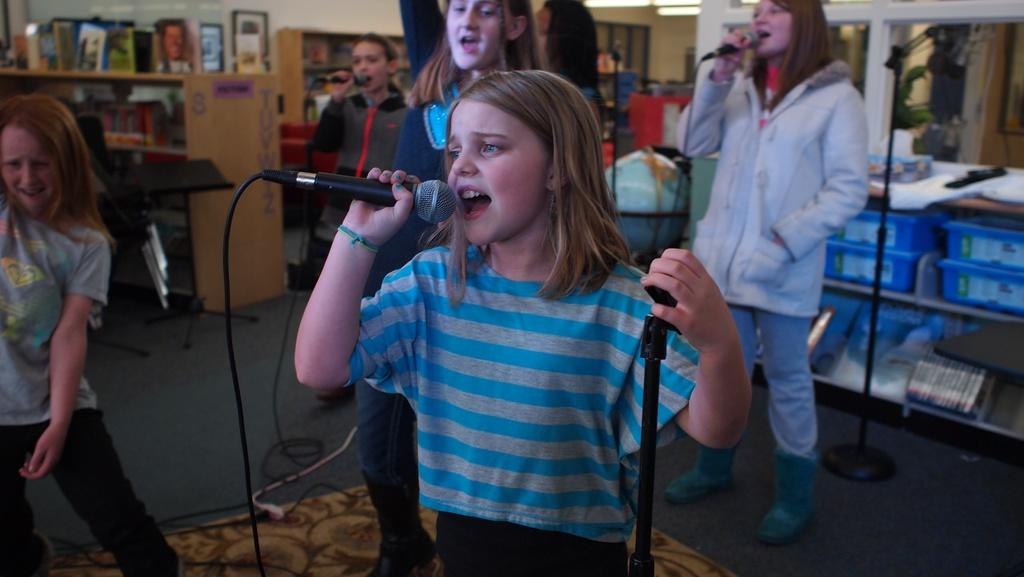What is the main subject of the image? The main subject of the image is a group of girls. What are the girls holding in the image? The girls are holding a microphone. What can be seen in the background of the image? There is a shelf in the background of the image. What type of clam is visible on the shelf in the image? There is no clam visible on the shelf in the image. What kind of system is being used by the girls to communicate in the image? The image does not show any communication system being used by the girls; they are simply holding a microphone. 